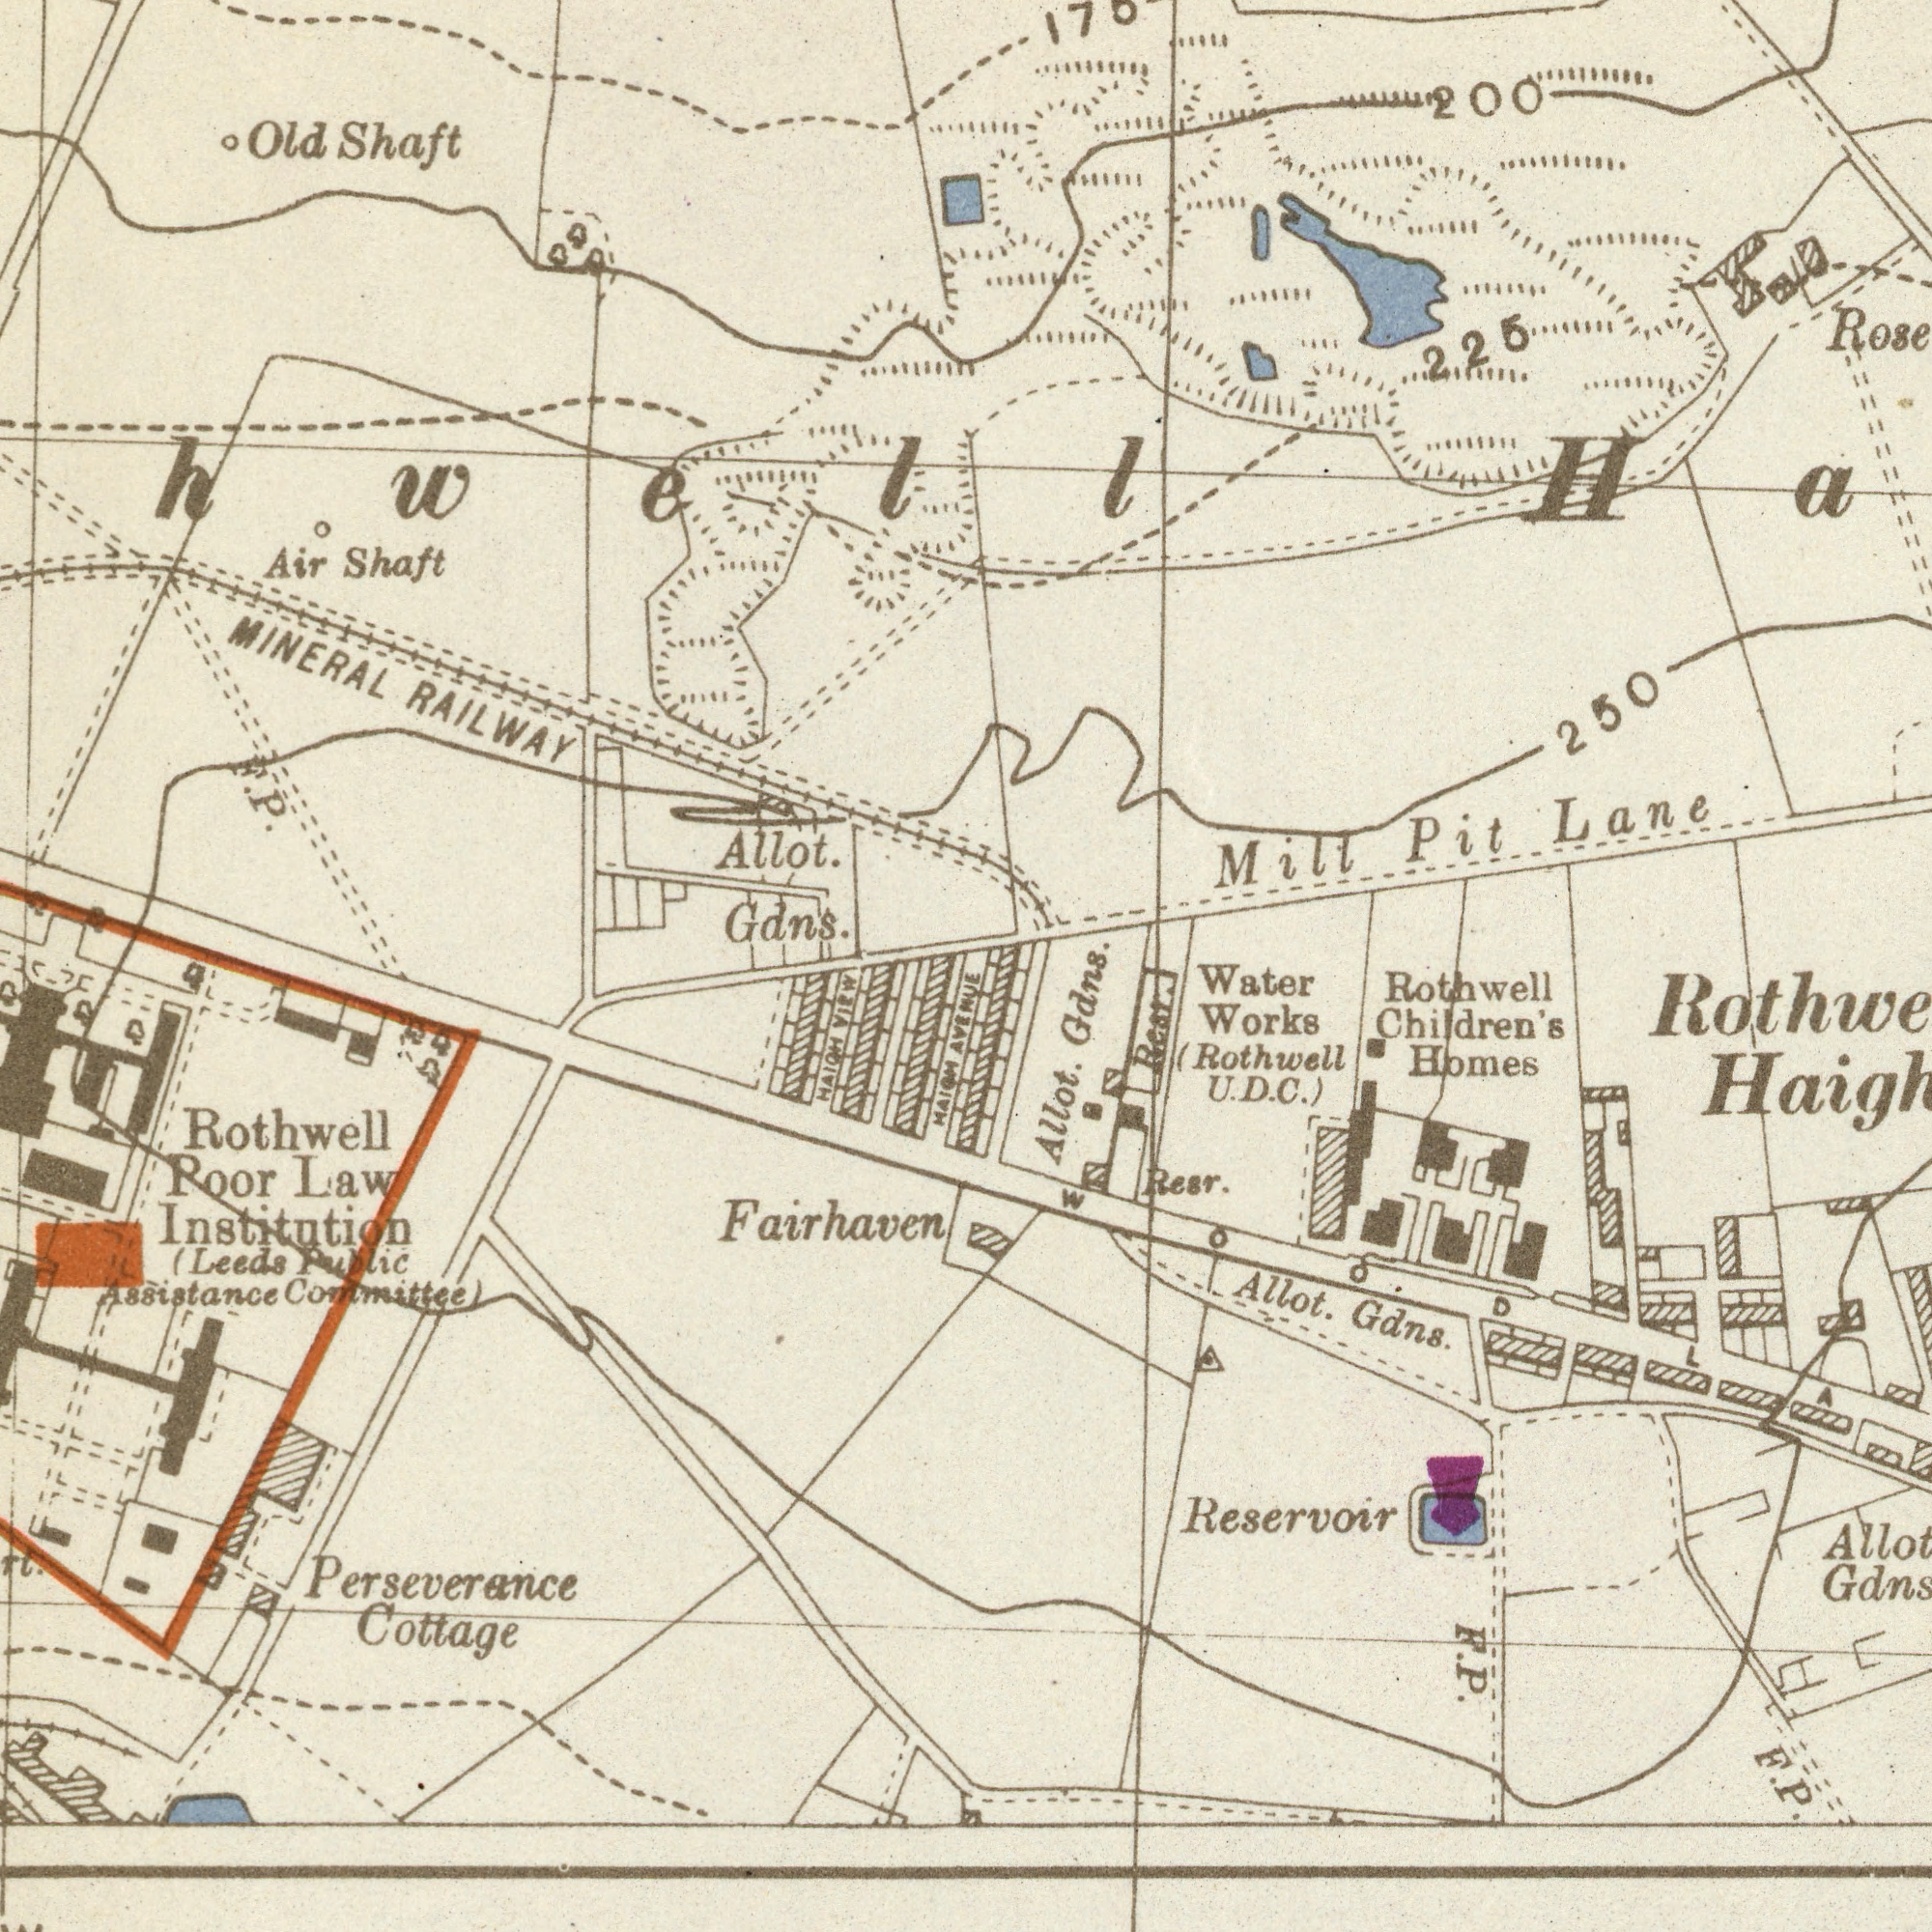What text is shown in the top-right quadrant? Mill Pit Lane 250 225 200 What text appears in the bottom-right area of the image? AVENUE Reservoir Allot. Gdns. Rothwell Children's Homes Water Works (Rothwell U. D. C.) Allot. Gdns. Resr. Resr. F. P. F. P. WOOD What text can you see in the top-left section? MINERAL RAILWAY Allot. Gdns. Old Shaft Air Shaft ###hwell F. P. What text is visible in the lower-left corner? Rothwell Roor Law Institution (Leeds Public Assistance Committee Fairhaven Perseverance Cottage HAIGH VIEW HAIGH 